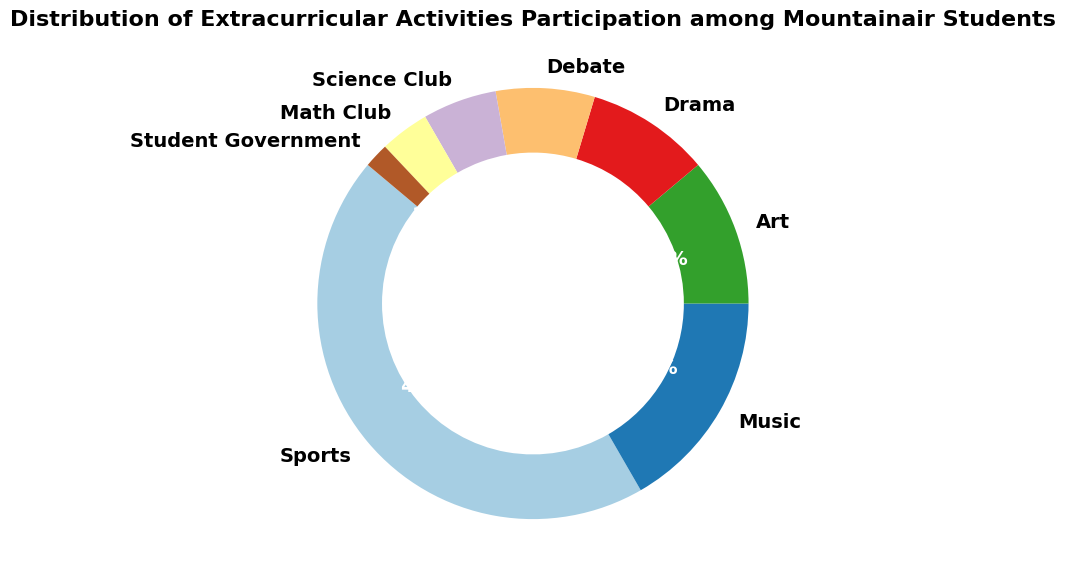What's the largest group of extracurricular activity participation? To find the largest group, look for the slice with the highest percentage. The Sports section has the largest slice with 120 participants, accounting for 49.2% of the total.
Answer: Sports Which activity has the least participation? Identify the smallest slice in the ring chart, which is Student Government with 5 participants, making up the smallest part of the circle.
Answer: Student Government What is the combined percentage of participation for Music and Art? Add the percentages of Music (18.4%) and Art (12.3%) from the chart slices. 18.4% + 12.3% = 30.7%.
Answer: 30.7% How much larger is participation in Sports than in Science Club? Find the difference in participation between Sports (120) and Science Club (15). 120 - 15 = 105 participants.
Answer: 105 What percentage of students participate in Drama and Debate combined? Add the percentages of Drama (10.2%) and Debate (8.2%) from the slices. 10.2% + 8.2% = 18.4%.
Answer: 18.4% Which has a higher participation rate: Math Club or Student Government? Compare the percentages. Math Club has 4.1% while Student Government has 2.0%. Therefore, Math Club has a higher participation rate.
Answer: Math Club How does the participation in Music compare to Drama and Debate combined? Compare Music's percentage (18.4%) to the sum of Drama and Debate (10.2% + 8.2% = 18.4%). Both are equal at 18.4%.
Answer: Equal What are the visual color differences between the largest and smallest participation groups? The largest group (Sports) is colored distinctively compared to the smallest group (Student Government). Visually, the colors differ significantly to enhance distinction.
Answer: Distinctive What fraction of the total participation do the Art and Science Club activities make up together? Convert their percentages to fractions: Art (30) is approximately 12.3% and Science Club (15) is approximately 6.1%. Combined, they make up approximately 18.4% of the total.
Answer: Approximately 18.4% What is the average number of participants in Music, Art, and Drama? Sum the participants in these activities: Music (45), Art (30), Drama (25), then divide by the number of activities. (45 + 30 + 25) / 3 = 33.33 participants.
Answer: 33.33 